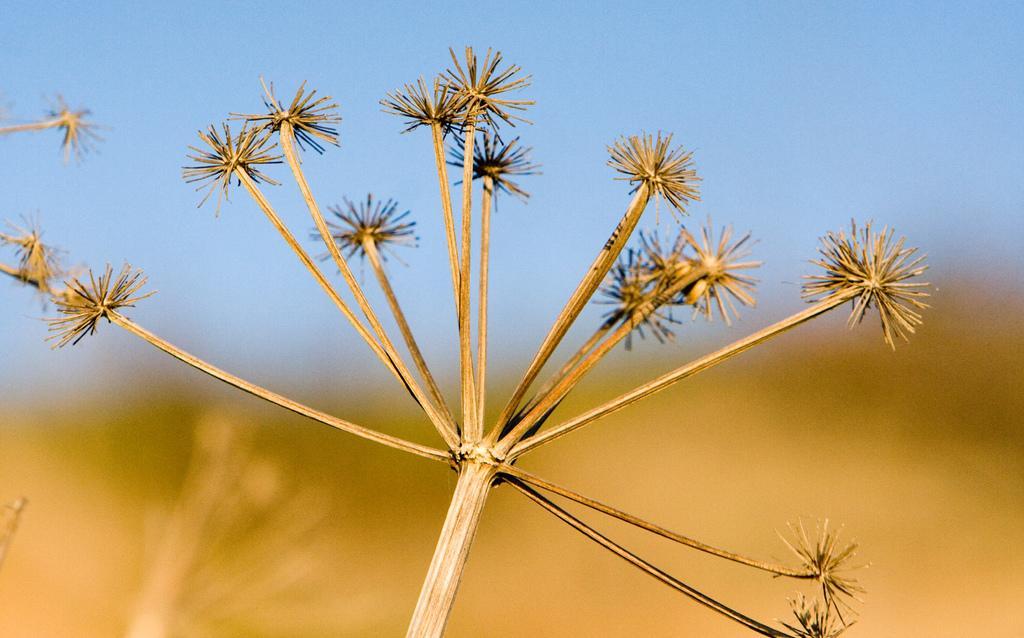Could you give a brief overview of what you see in this image? In the foreground of this image, it seems like a plant and the background image is blur. 